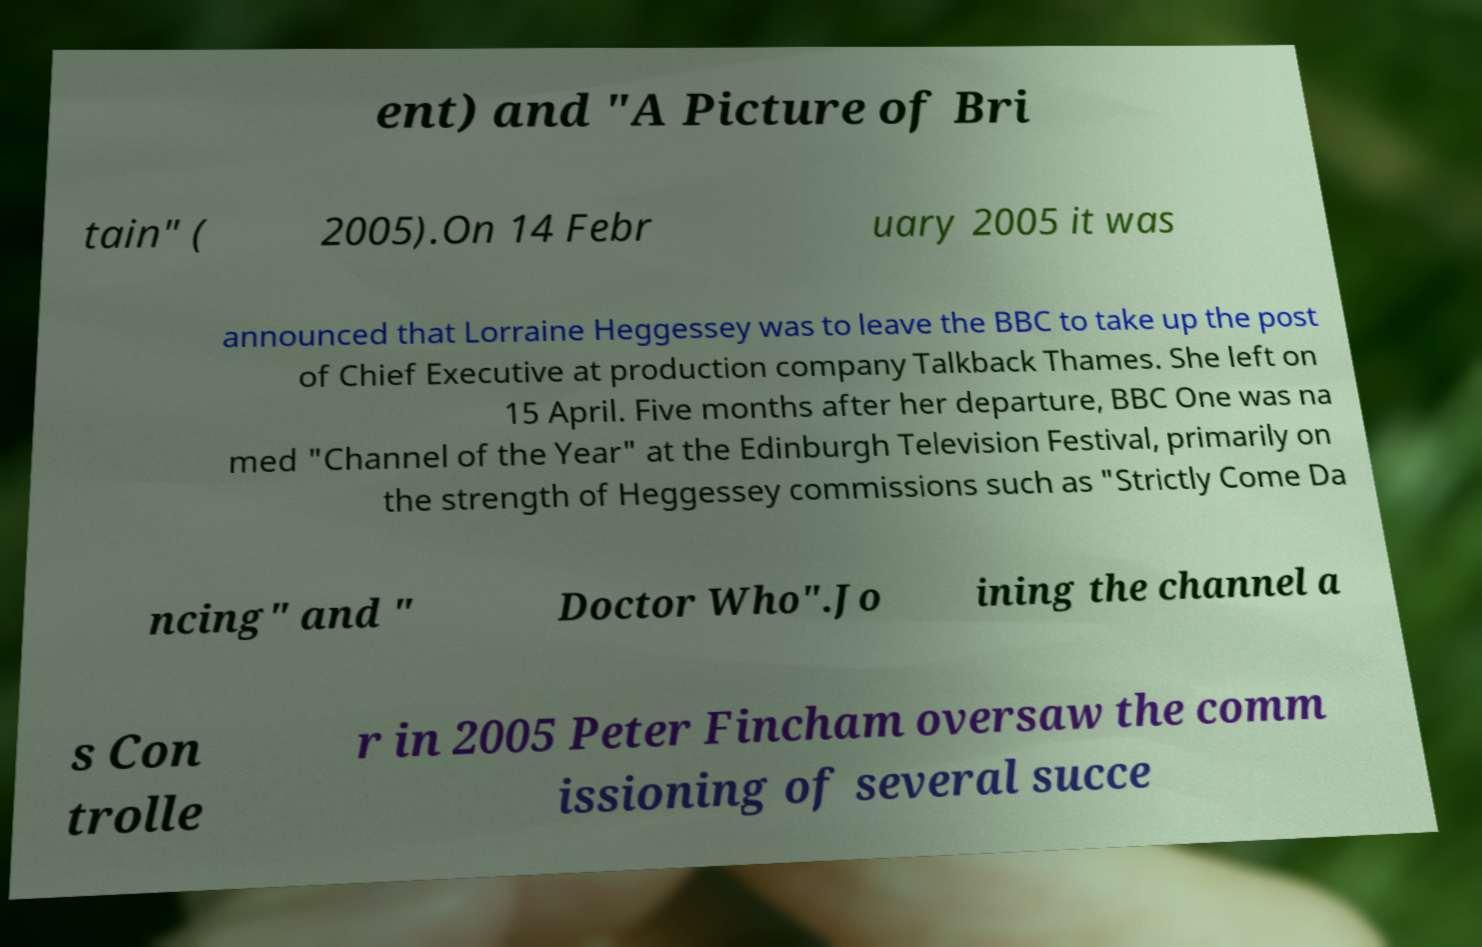What messages or text are displayed in this image? I need them in a readable, typed format. ent) and "A Picture of Bri tain" ( 2005).On 14 Febr uary 2005 it was announced that Lorraine Heggessey was to leave the BBC to take up the post of Chief Executive at production company Talkback Thames. She left on 15 April. Five months after her departure, BBC One was na med "Channel of the Year" at the Edinburgh Television Festival, primarily on the strength of Heggessey commissions such as "Strictly Come Da ncing" and " Doctor Who".Jo ining the channel a s Con trolle r in 2005 Peter Fincham oversaw the comm issioning of several succe 